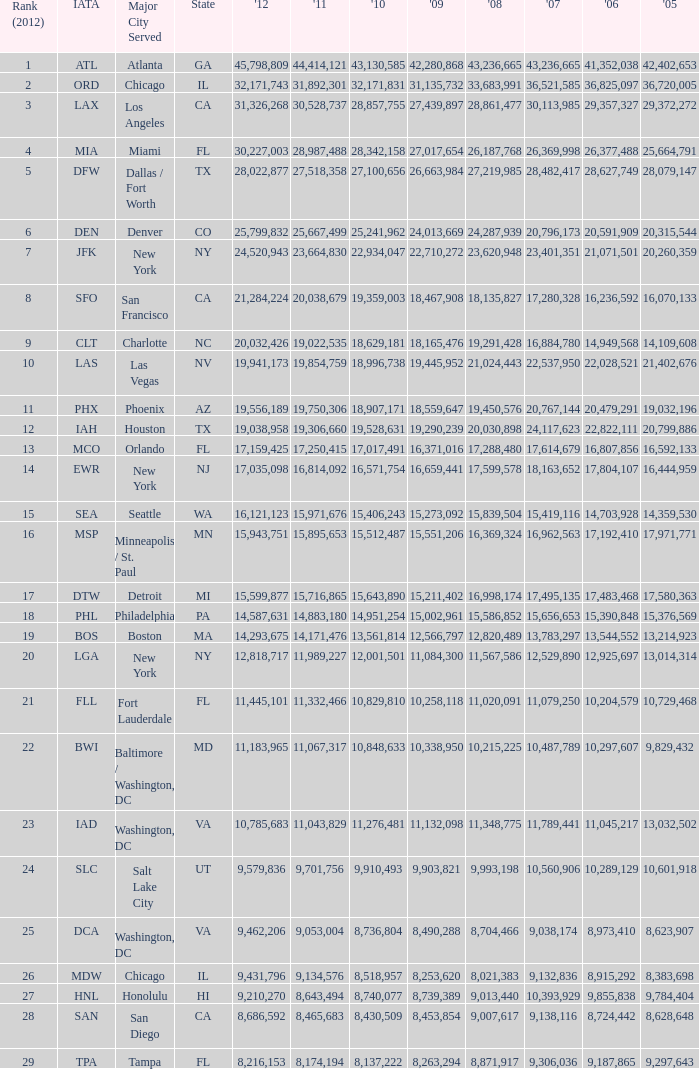I'm looking to parse the entire table for insights. Could you assist me with that? {'header': ['Rank (2012)', 'IATA', 'Major City Served', 'State', "'12", "'11", "'10", "'09", "'08", "'07", "'06", "'05"], 'rows': [['1', 'ATL', 'Atlanta', 'GA', '45,798,809', '44,414,121', '43,130,585', '42,280,868', '43,236,665', '43,236,665', '41,352,038', '42,402,653'], ['2', 'ORD', 'Chicago', 'IL', '32,171,743', '31,892,301', '32,171,831', '31,135,732', '33,683,991', '36,521,585', '36,825,097', '36,720,005'], ['3', 'LAX', 'Los Angeles', 'CA', '31,326,268', '30,528,737', '28,857,755', '27,439,897', '28,861,477', '30,113,985', '29,357,327', '29,372,272'], ['4', 'MIA', 'Miami', 'FL', '30,227,003', '28,987,488', '28,342,158', '27,017,654', '26,187,768', '26,369,998', '26,377,488', '25,664,791'], ['5', 'DFW', 'Dallas / Fort Worth', 'TX', '28,022,877', '27,518,358', '27,100,656', '26,663,984', '27,219,985', '28,482,417', '28,627,749', '28,079,147'], ['6', 'DEN', 'Denver', 'CO', '25,799,832', '25,667,499', '25,241,962', '24,013,669', '24,287,939', '20,796,173', '20,591,909', '20,315,544'], ['7', 'JFK', 'New York', 'NY', '24,520,943', '23,664,830', '22,934,047', '22,710,272', '23,620,948', '23,401,351', '21,071,501', '20,260,359'], ['8', 'SFO', 'San Francisco', 'CA', '21,284,224', '20,038,679', '19,359,003', '18,467,908', '18,135,827', '17,280,328', '16,236,592', '16,070,133'], ['9', 'CLT', 'Charlotte', 'NC', '20,032,426', '19,022,535', '18,629,181', '18,165,476', '19,291,428', '16,884,780', '14,949,568', '14,109,608'], ['10', 'LAS', 'Las Vegas', 'NV', '19,941,173', '19,854,759', '18,996,738', '19,445,952', '21,024,443', '22,537,950', '22,028,521', '21,402,676'], ['11', 'PHX', 'Phoenix', 'AZ', '19,556,189', '19,750,306', '18,907,171', '18,559,647', '19,450,576', '20,767,144', '20,479,291', '19,032,196'], ['12', 'IAH', 'Houston', 'TX', '19,038,958', '19,306,660', '19,528,631', '19,290,239', '20,030,898', '24,117,623', '22,822,111', '20,799,886'], ['13', 'MCO', 'Orlando', 'FL', '17,159,425', '17,250,415', '17,017,491', '16,371,016', '17,288,480', '17,614,679', '16,807,856', '16,592,133'], ['14', 'EWR', 'New York', 'NJ', '17,035,098', '16,814,092', '16,571,754', '16,659,441', '17,599,578', '18,163,652', '17,804,107', '16,444,959'], ['15', 'SEA', 'Seattle', 'WA', '16,121,123', '15,971,676', '15,406,243', '15,273,092', '15,839,504', '15,419,116', '14,703,928', '14,359,530'], ['16', 'MSP', 'Minneapolis / St. Paul', 'MN', '15,943,751', '15,895,653', '15,512,487', '15,551,206', '16,369,324', '16,962,563', '17,192,410', '17,971,771'], ['17', 'DTW', 'Detroit', 'MI', '15,599,877', '15,716,865', '15,643,890', '15,211,402', '16,998,174', '17,495,135', '17,483,468', '17,580,363'], ['18', 'PHL', 'Philadelphia', 'PA', '14,587,631', '14,883,180', '14,951,254', '15,002,961', '15,586,852', '15,656,653', '15,390,848', '15,376,569'], ['19', 'BOS', 'Boston', 'MA', '14,293,675', '14,171,476', '13,561,814', '12,566,797', '12,820,489', '13,783,297', '13,544,552', '13,214,923'], ['20', 'LGA', 'New York', 'NY', '12,818,717', '11,989,227', '12,001,501', '11,084,300', '11,567,586', '12,529,890', '12,925,697', '13,014,314'], ['21', 'FLL', 'Fort Lauderdale', 'FL', '11,445,101', '11,332,466', '10,829,810', '10,258,118', '11,020,091', '11,079,250', '10,204,579', '10,729,468'], ['22', 'BWI', 'Baltimore / Washington, DC', 'MD', '11,183,965', '11,067,317', '10,848,633', '10,338,950', '10,215,225', '10,487,789', '10,297,607', '9,829,432'], ['23', 'IAD', 'Washington, DC', 'VA', '10,785,683', '11,043,829', '11,276,481', '11,132,098', '11,348,775', '11,789,441', '11,045,217', '13,032,502'], ['24', 'SLC', 'Salt Lake City', 'UT', '9,579,836', '9,701,756', '9,910,493', '9,903,821', '9,993,198', '10,560,906', '10,289,129', '10,601,918'], ['25', 'DCA', 'Washington, DC', 'VA', '9,462,206', '9,053,004', '8,736,804', '8,490,288', '8,704,466', '9,038,174', '8,973,410', '8,623,907'], ['26', 'MDW', 'Chicago', 'IL', '9,431,796', '9,134,576', '8,518,957', '8,253,620', '8,021,383', '9,132,836', '8,915,292', '8,383,698'], ['27', 'HNL', 'Honolulu', 'HI', '9,210,270', '8,643,494', '8,740,077', '8,739,389', '9,013,440', '10,393,929', '9,855,838', '9,784,404'], ['28', 'SAN', 'San Diego', 'CA', '8,686,592', '8,465,683', '8,430,509', '8,453,854', '9,007,617', '9,138,116', '8,724,442', '8,628,648'], ['29', 'TPA', 'Tampa', 'FL', '8,216,153', '8,174,194', '8,137,222', '8,263,294', '8,871,917', '9,306,036', '9,187,865', '9,297,643']]} What is the greatest 2010 for Miami, Fl? 28342158.0. 